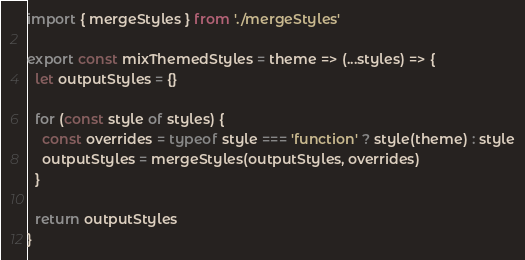Convert code to text. <code><loc_0><loc_0><loc_500><loc_500><_JavaScript_>import { mergeStyles } from './mergeStyles'

export const mixThemedStyles = theme => (...styles) => {
  let outputStyles = {}

  for (const style of styles) {
    const overrides = typeof style === 'function' ? style(theme) : style
    outputStyles = mergeStyles(outputStyles, overrides)
  }

  return outputStyles
}
</code> 